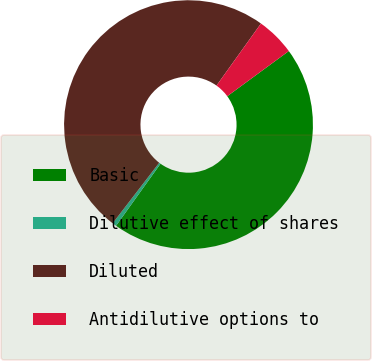<chart> <loc_0><loc_0><loc_500><loc_500><pie_chart><fcel>Basic<fcel>Dilutive effect of shares<fcel>Diluted<fcel>Antidilutive options to<nl><fcel>44.97%<fcel>0.54%<fcel>49.46%<fcel>5.03%<nl></chart> 